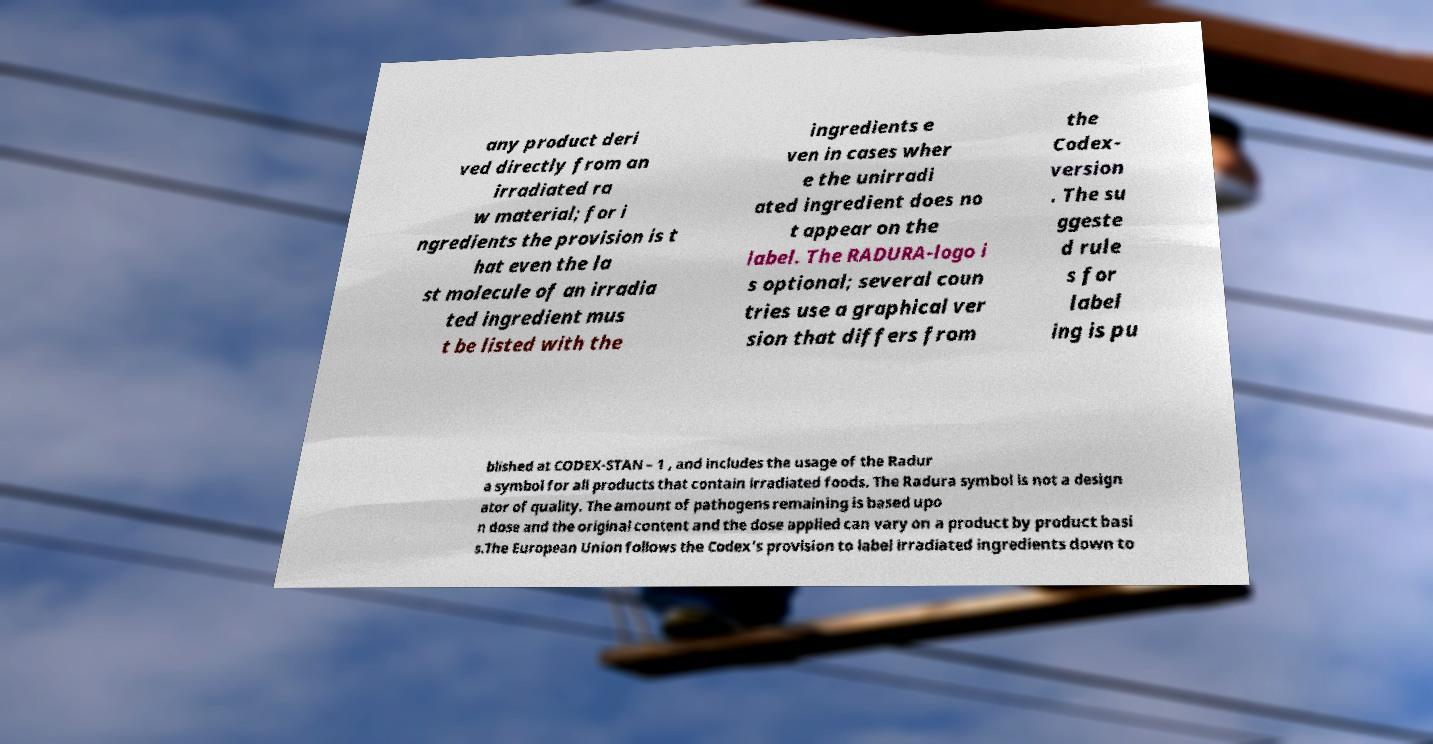For documentation purposes, I need the text within this image transcribed. Could you provide that? any product deri ved directly from an irradiated ra w material; for i ngredients the provision is t hat even the la st molecule of an irradia ted ingredient mus t be listed with the ingredients e ven in cases wher e the unirradi ated ingredient does no t appear on the label. The RADURA-logo i s optional; several coun tries use a graphical ver sion that differs from the Codex- version . The su ggeste d rule s for label ing is pu blished at CODEX-STAN – 1 , and includes the usage of the Radur a symbol for all products that contain irradiated foods. The Radura symbol is not a design ator of quality. The amount of pathogens remaining is based upo n dose and the original content and the dose applied can vary on a product by product basi s.The European Union follows the Codex's provision to label irradiated ingredients down to 